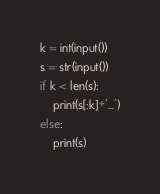<code> <loc_0><loc_0><loc_500><loc_500><_Python_>k = int(input())
s = str(input())
if k < len(s):
    print(s[:k]+'...')
else:
    print(s)</code> 